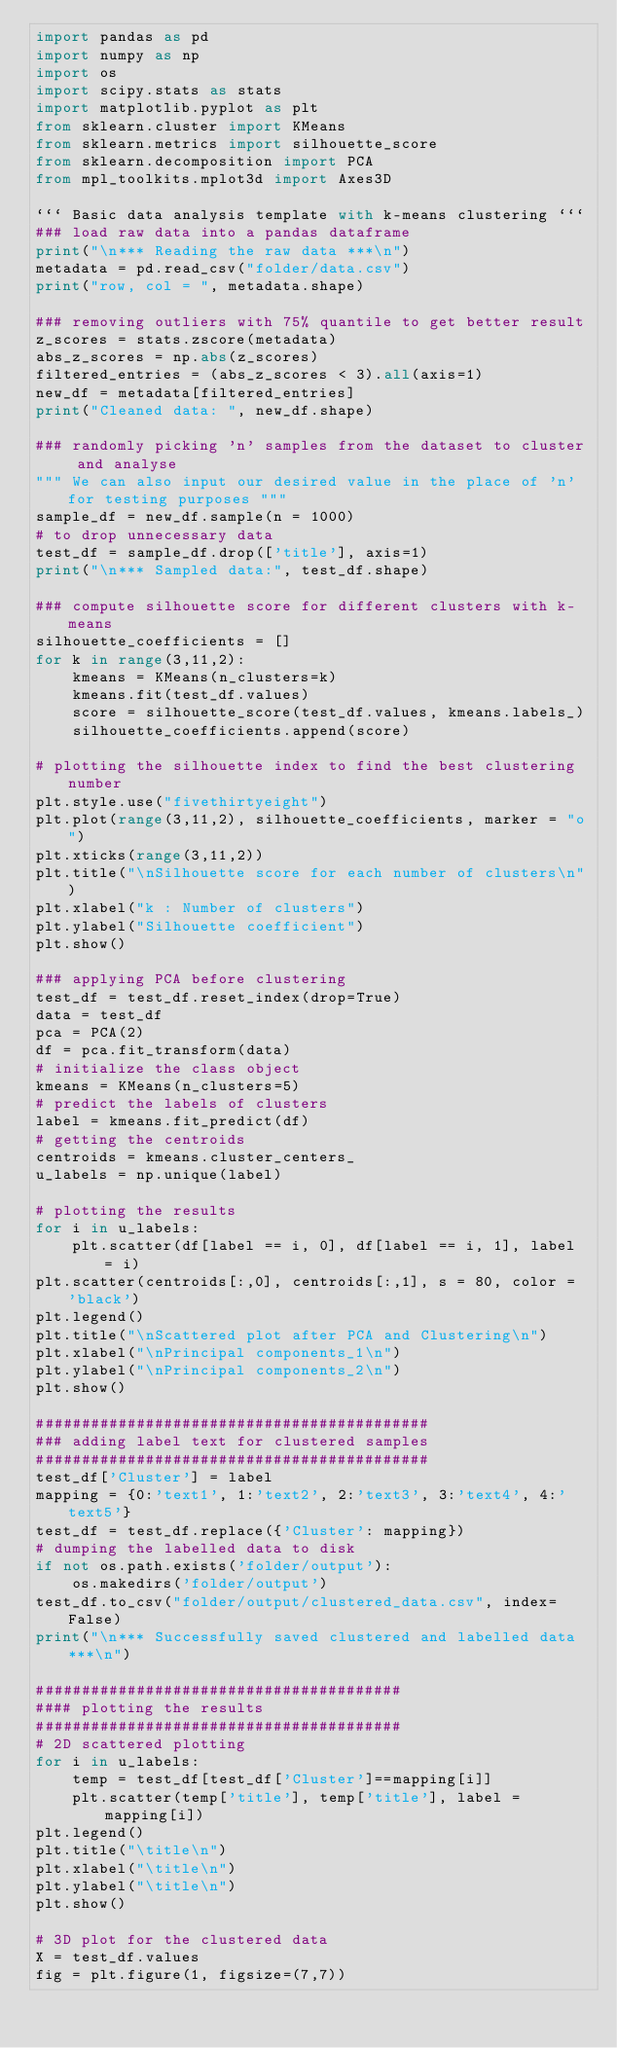Convert code to text. <code><loc_0><loc_0><loc_500><loc_500><_Python_>import pandas as pd
import numpy as np
import os
import scipy.stats as stats
import matplotlib.pyplot as plt
from sklearn.cluster import KMeans
from sklearn.metrics import silhouette_score
from sklearn.decomposition import PCA
from mpl_toolkits.mplot3d import Axes3D

``` Basic data analysis template with k-means clustering ```
### load raw data into a pandas dataframe
print("\n*** Reading the raw data ***\n")
metadata = pd.read_csv("folder/data.csv")
print("row, col = ", metadata.shape)

### removing outliers with 75% quantile to get better result
z_scores = stats.zscore(metadata)
abs_z_scores = np.abs(z_scores)
filtered_entries = (abs_z_scores < 3).all(axis=1)
new_df = metadata[filtered_entries]
print("Cleaned data: ", new_df.shape)

### randomly picking 'n' samples from the dataset to cluster and analyse
""" We can also input our desired value in the place of 'n' for testing purposes """
sample_df = new_df.sample(n = 1000)
# to drop unnecessary data
test_df = sample_df.drop(['title'], axis=1)
print("\n*** Sampled data:", test_df.shape)

### compute silhouette score for different clusters with k-means
silhouette_coefficients = []
for k in range(3,11,2):
    kmeans = KMeans(n_clusters=k)
    kmeans.fit(test_df.values)
    score = silhouette_score(test_df.values, kmeans.labels_)
    silhouette_coefficients.append(score)

# plotting the silhouette index to find the best clustering number
plt.style.use("fivethirtyeight")
plt.plot(range(3,11,2), silhouette_coefficients, marker = "o")
plt.xticks(range(3,11,2))
plt.title("\nSilhouette score for each number of clusters\n")
plt.xlabel("k : Number of clusters")
plt.ylabel("Silhouette coefficient")
plt.show()

### applying PCA before clustering
test_df = test_df.reset_index(drop=True)
data = test_df
pca = PCA(2)
df = pca.fit_transform(data)
# initialize the class object
kmeans = KMeans(n_clusters=5)
# predict the labels of clusters
label = kmeans.fit_predict(df)
# getting the centroids
centroids = kmeans.cluster_centers_
u_labels = np.unique(label)

# plotting the results
for i in u_labels:
    plt.scatter(df[label == i, 0], df[label == i, 1], label = i)
plt.scatter(centroids[:,0], centroids[:,1], s = 80, color = 'black')
plt.legend()
plt.title("\nScattered plot after PCA and Clustering\n")
plt.xlabel("\nPrincipal components_1\n")
plt.ylabel("\nPrincipal components_2\n")
plt.show()

###########################################
### adding label text for clustered samples
###########################################
test_df['Cluster'] = label
mapping = {0:'text1', 1:'text2', 2:'text3', 3:'text4', 4:'text5'}
test_df = test_df.replace({'Cluster': mapping})
# dumping the labelled data to disk
if not os.path.exists('folder/output'):
    os.makedirs('folder/output')
test_df.to_csv("folder/output/clustered_data.csv", index=False)
print("\n*** Successfully saved clustered and labelled data ***\n")

########################################
#### plotting the results
########################################
# 2D scattered plotting
for i in u_labels:
    temp = test_df[test_df['Cluster']==mapping[i]]
    plt.scatter(temp['title'], temp['title'], label = mapping[i])
plt.legend()
plt.title("\title\n")
plt.xlabel("\title\n")
plt.ylabel("\title\n")
plt.show()

# 3D plot for the clustered data
X = test_df.values
fig = plt.figure(1, figsize=(7,7))</code> 